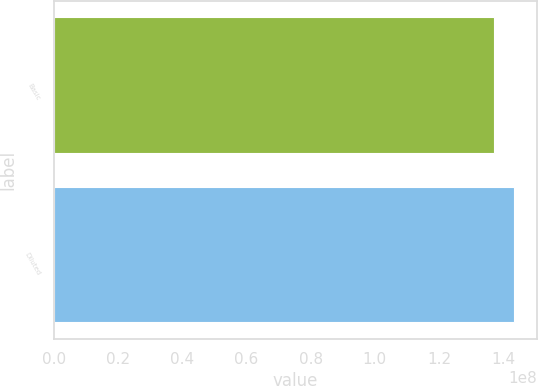Convert chart to OTSL. <chart><loc_0><loc_0><loc_500><loc_500><bar_chart><fcel>Basic<fcel>Diluted<nl><fcel>1.37097e+08<fcel>1.43315e+08<nl></chart> 